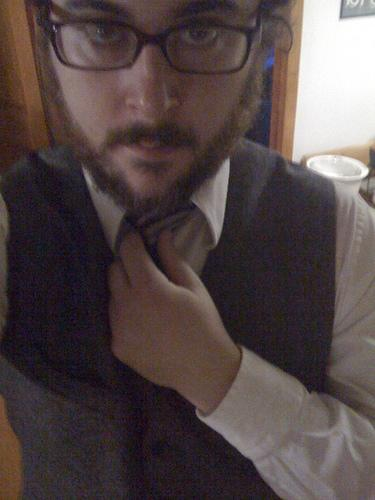What is the man adjusting? Please explain your reasoning. tie. The man has a tie. 